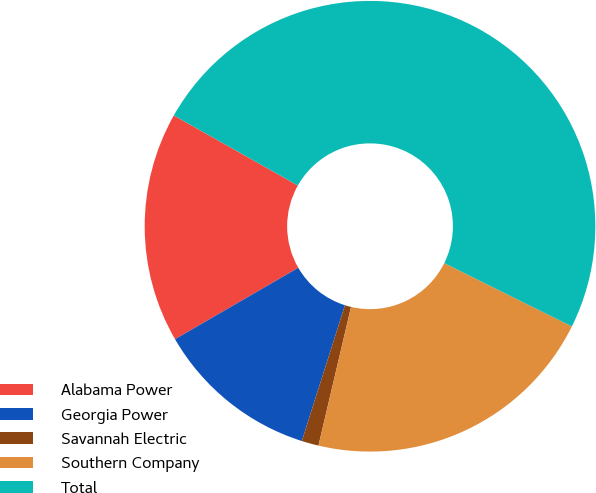<chart> <loc_0><loc_0><loc_500><loc_500><pie_chart><fcel>Alabama Power<fcel>Georgia Power<fcel>Savannah Electric<fcel>Southern Company<fcel>Total<nl><fcel>16.54%<fcel>11.75%<fcel>1.22%<fcel>21.34%<fcel>49.15%<nl></chart> 